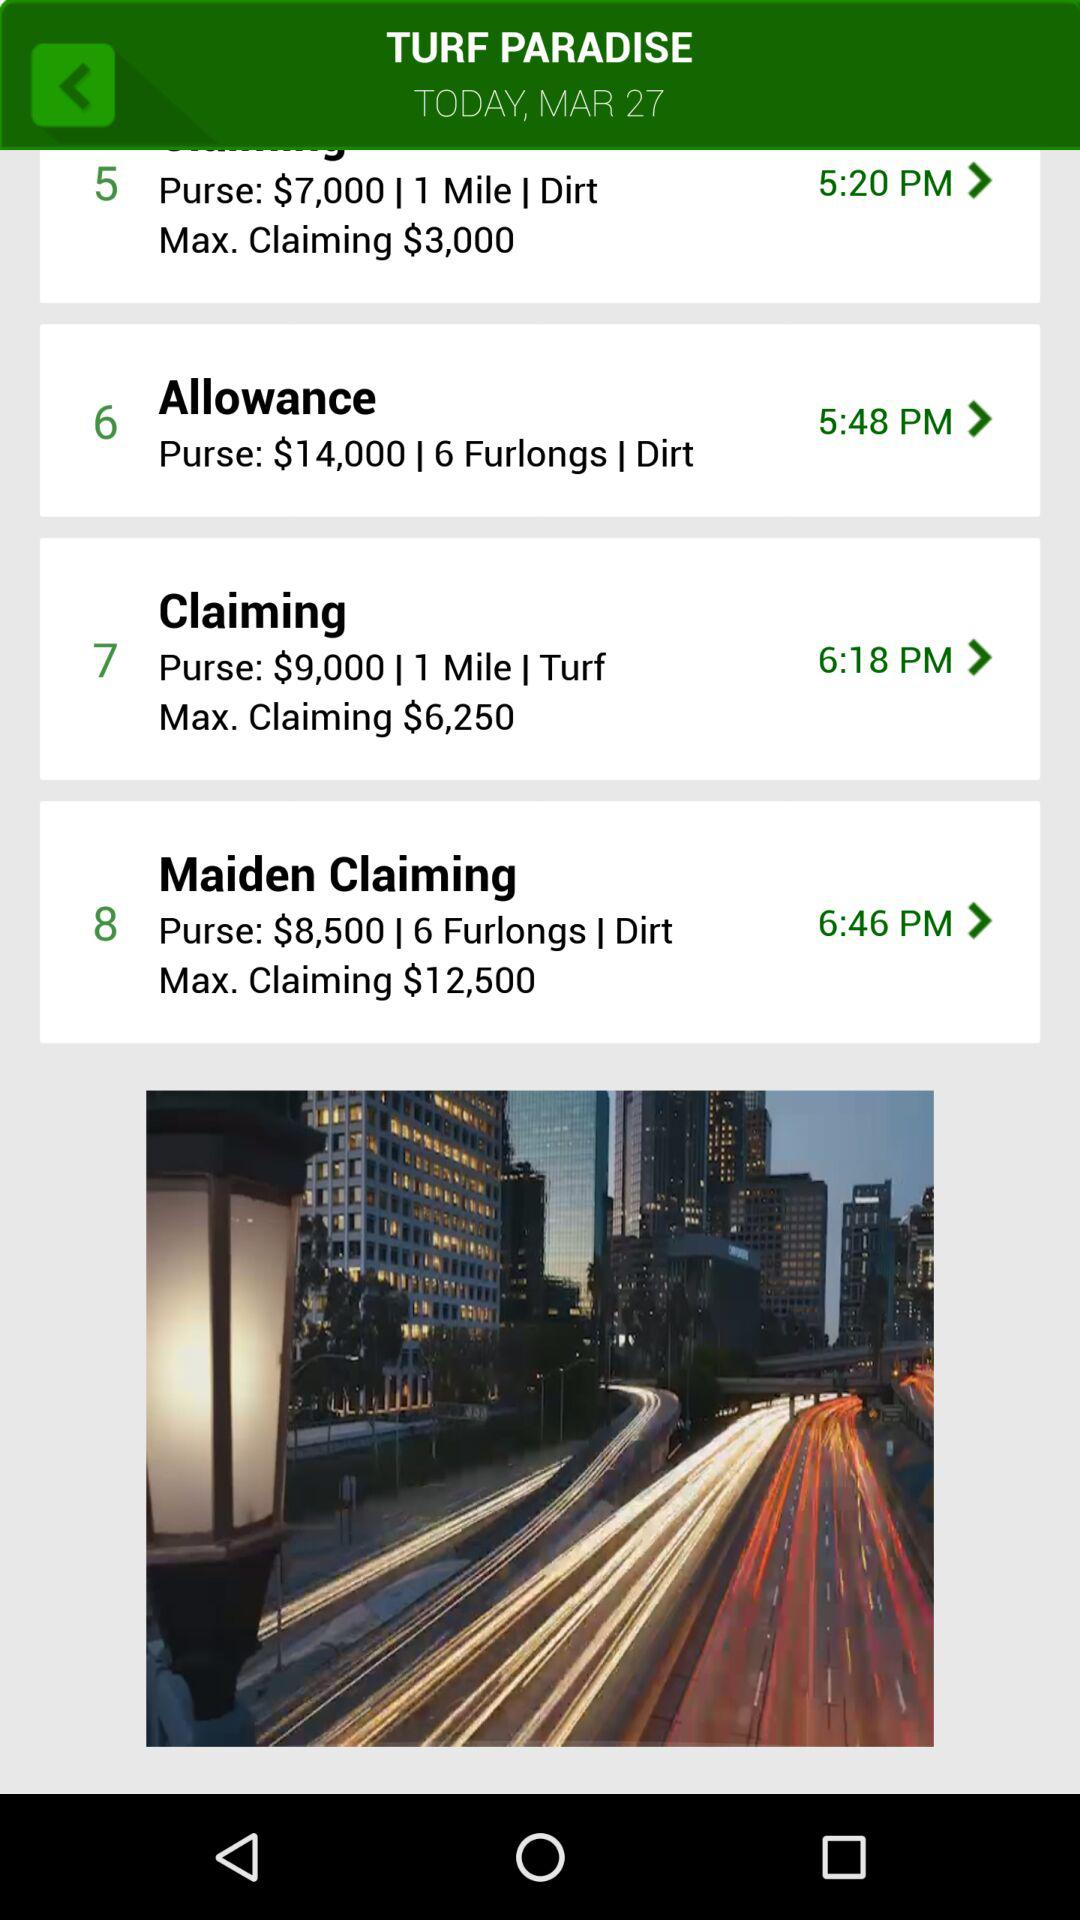How much is the maximum claiming amount in "Maiden Claiming"? The maximum claiming amount in "Maiden Claiming" is $12,500. 